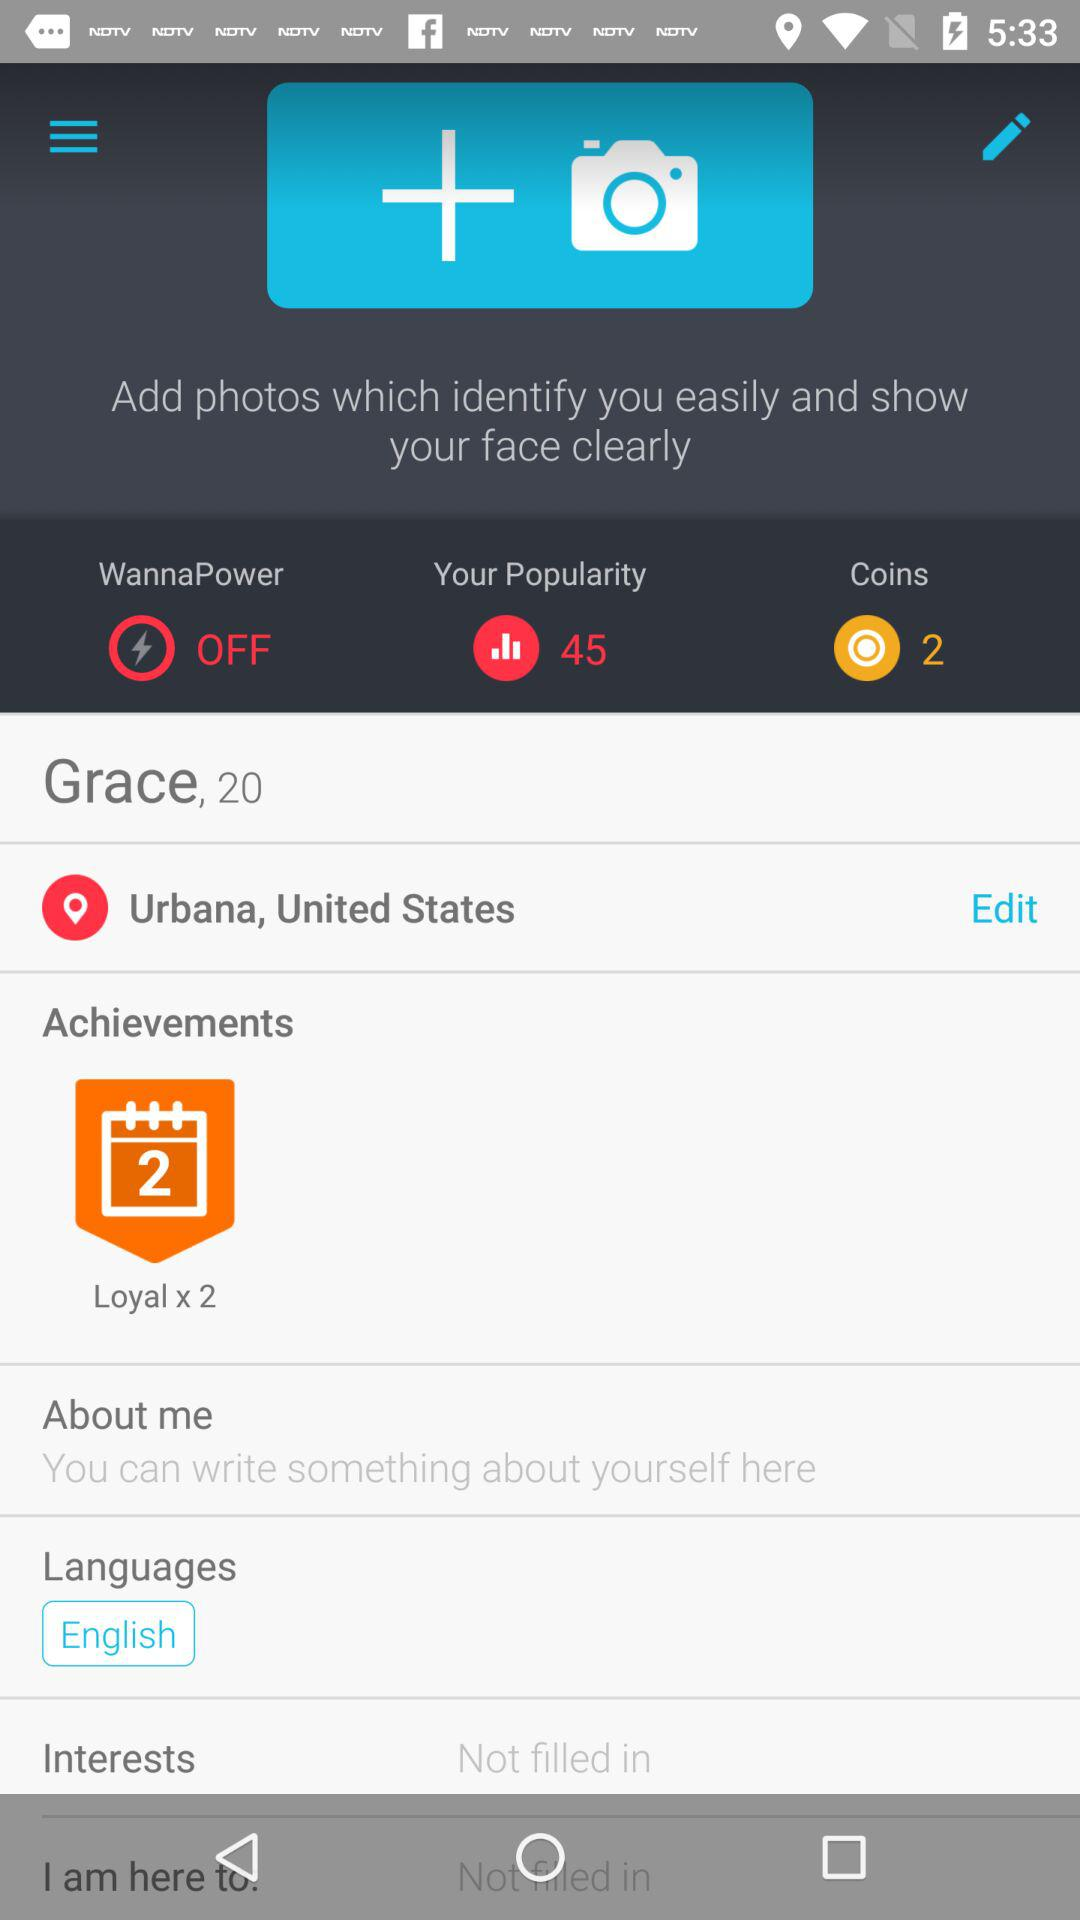What is the user name? The user name is Grace. 